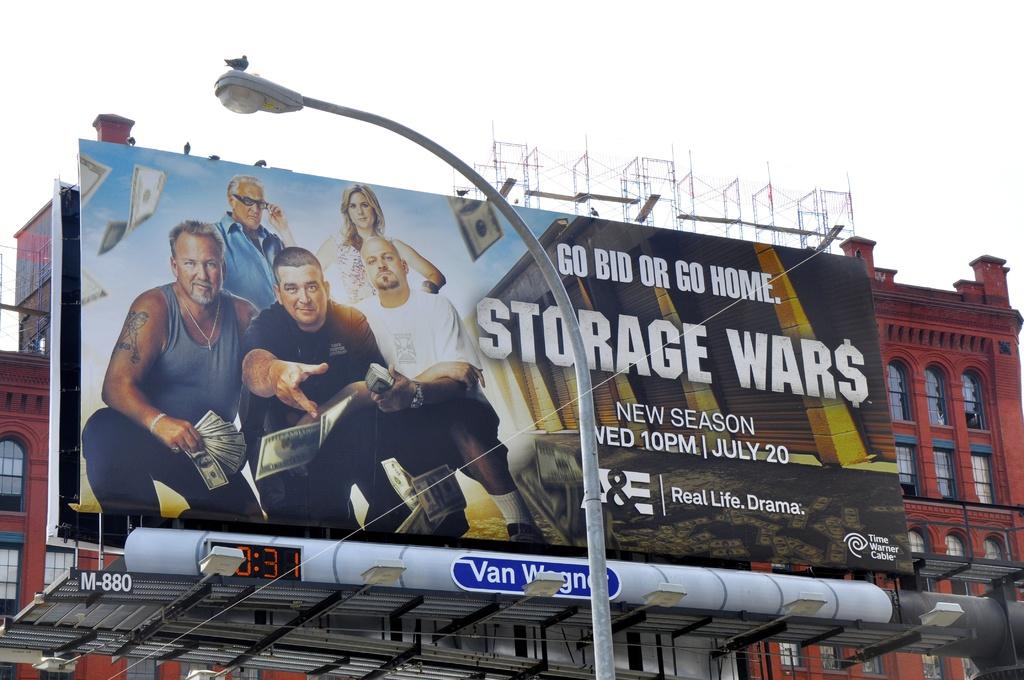What network is the show on?
Your answer should be very brief. A&e. 